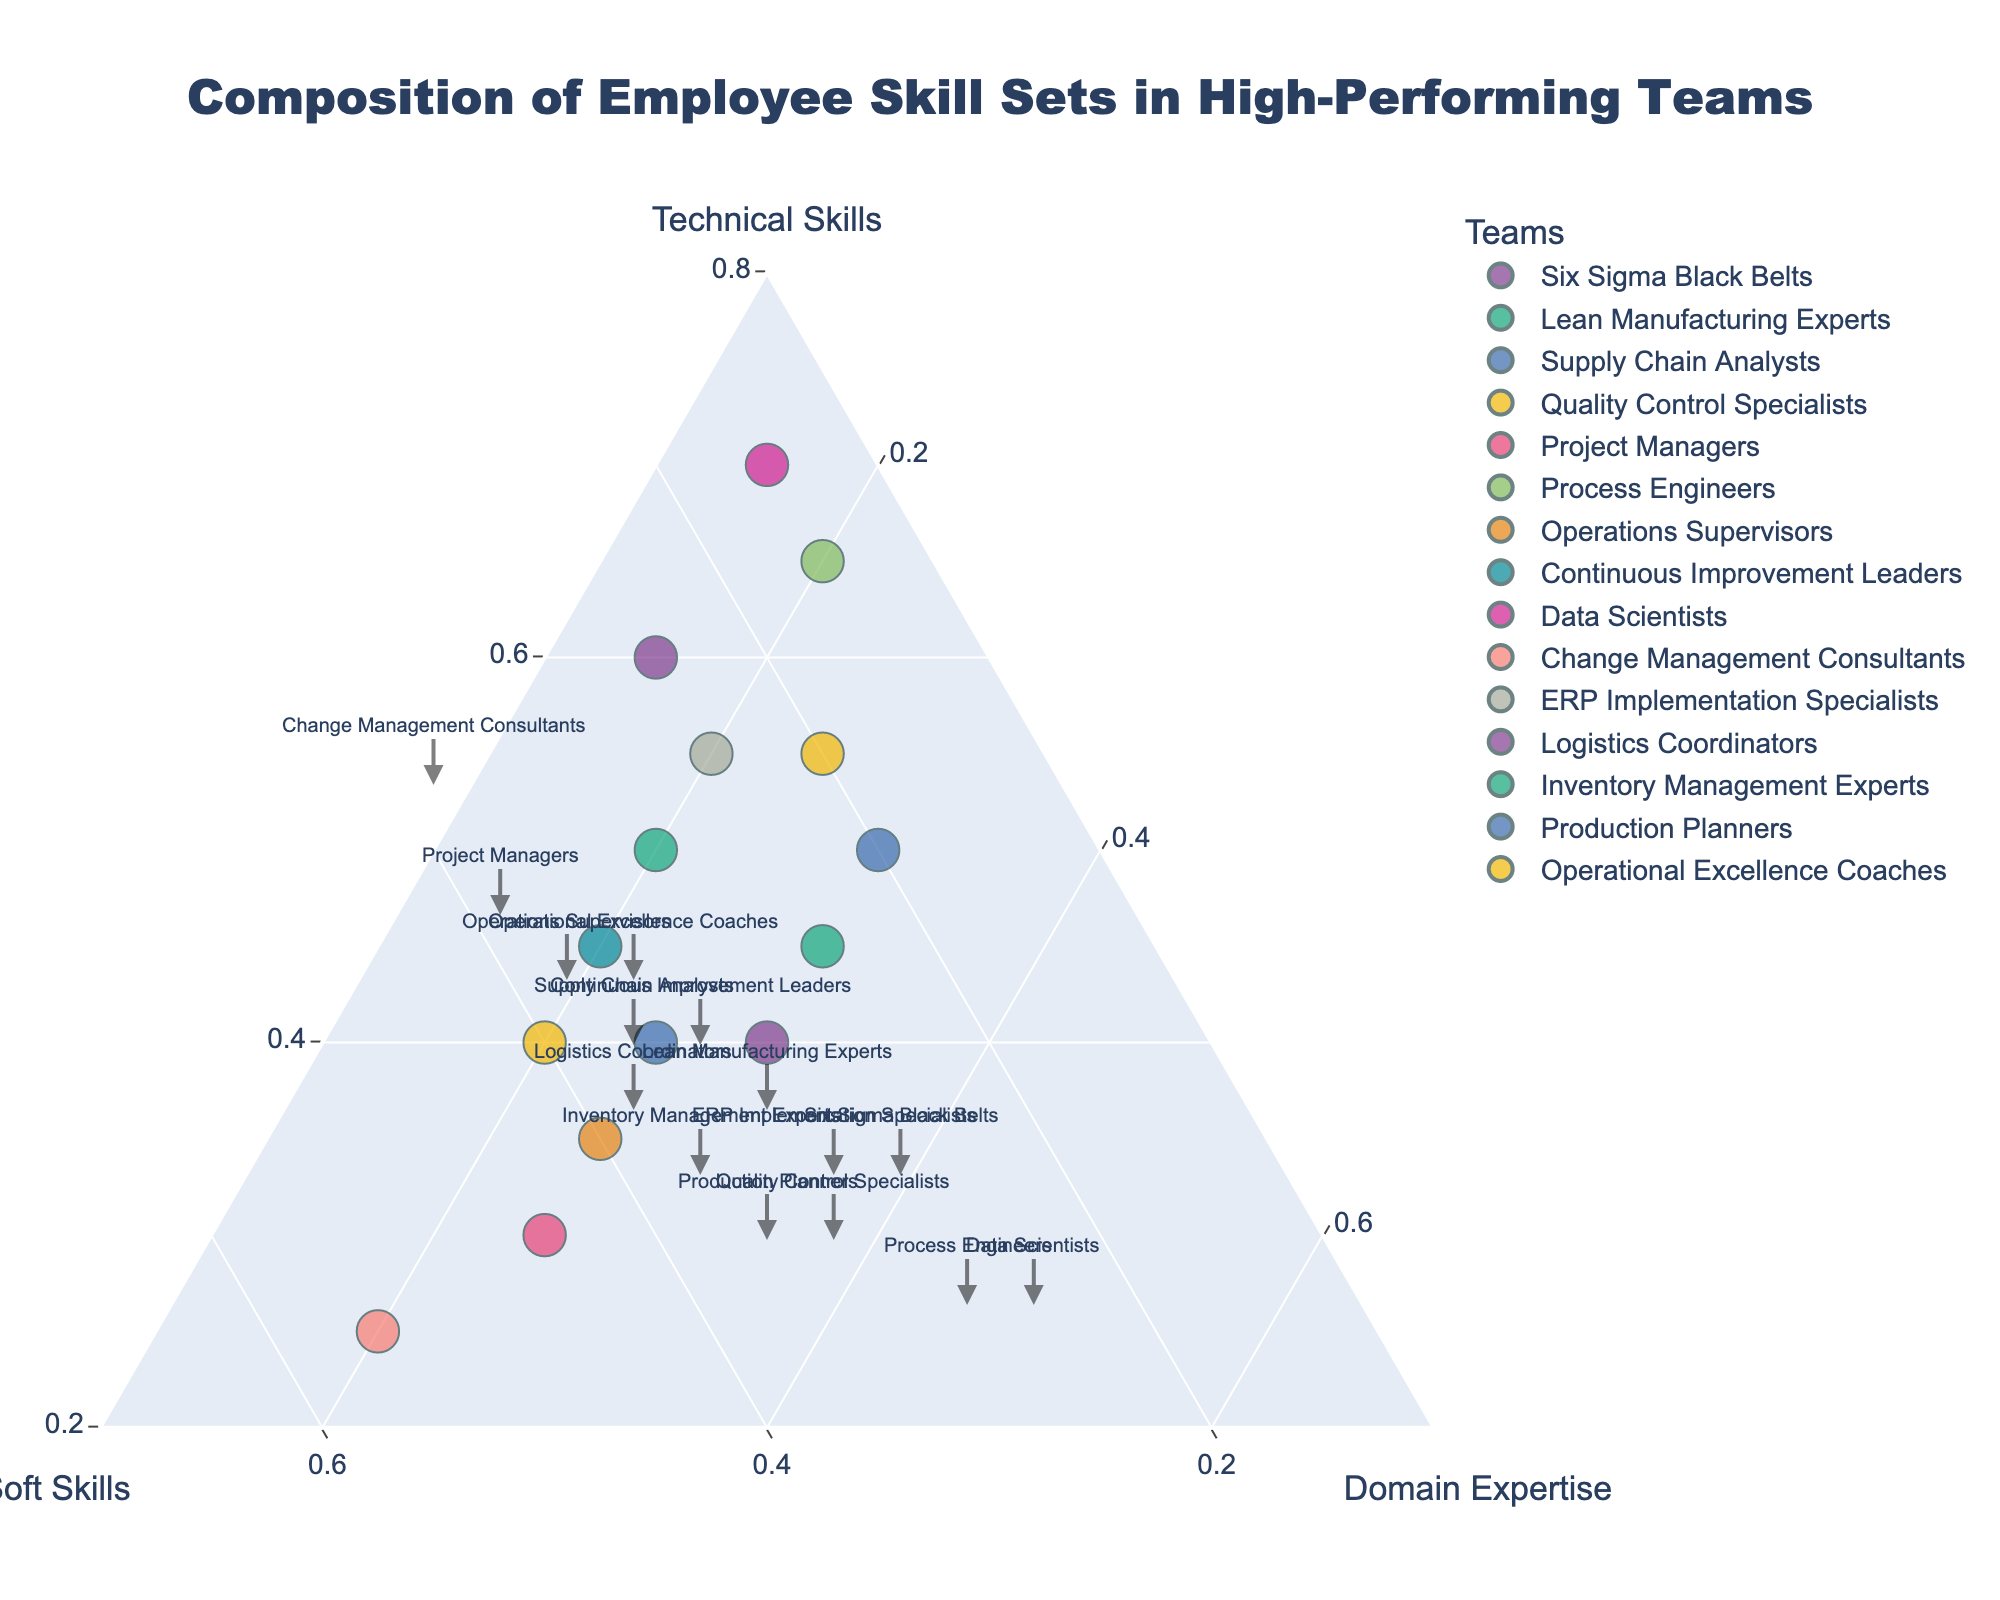What title is displayed on the figure? The title is located at the top center of the figure. It reads: "Composition of Employee Skill Sets in High-Performing Teams".
Answer: Composition of Employee Skill Sets in High-Performing Teams Which team has the highest percentage of Technical Skills? By observing the ternary plot, the Data Scientists team is positioned closest to the Technical Skills apex, indicating the highest percentage.
Answer: Data Scientists Which three teams have the highest percentage of Soft Skills? On the ternary plot, the teams positioned closest to the Soft Skills apex are Change Management Consultants, Project Managers, and Operations Supervisors.
Answer: Change Management Consultants, Project Managers, Operations Supervisors Compare Technical Skills percentage between Quality Control Specialists and ERP Implementation Specialists. Which one is higher? By looking at the ternary plot, Quality Control Specialists have a Technical Skills percentage closer to its apex than ERP Implementation Specialists, indicating a higher value.
Answer: Quality Control Specialists Which team has an equal percentage distribution of Soft Skills and Domain Expertise? The Logistics Coordinators team is located on the line between the Soft Skills and Domain Expertise apices, representing an equal distribution of these skills.
Answer: Logistics Coordinators What is the average percentage of Technical Skills for Lean Manufacturing Experts and Six Sigma Black Belts? Lean Manufacturing Experts have 50% and Six Sigma Black Belts 60% Technical Skills. The average percentage is (50 + 60) / 2 = 55%.
Answer: 55% Which team has the most balanced (close to equal) mix of Technical Skills, Soft Skills, and Domain Expertise? The team closest to the center of the ternary plot represents a balanced skill set. The Logistics Coordinators team is closest to the center.
Answer: Logistics Coordinators Compare the Total Skill sum of Data Scientists and Operational Excellence Coaches. Which team has a higher total sum? By observing the plot size and data, Data Scientists have 100 (70 + 15 + 15) and Operational Excellence Coaches have 100 (40 + 40 + 20). Both sums are equal.
Answer: They are equal Identify the team with the highest percentage of Domain Expertise. On the ternary plot, the Logistics Coordinators team is the closest to the Domain Expertise apex, indicating the highest percentage.
Answer: Logistics Coordinators What is the total number of teams represented in the figure? Count the distinct points or legends on the plot. There are 15 teams represented in total.
Answer: 15 